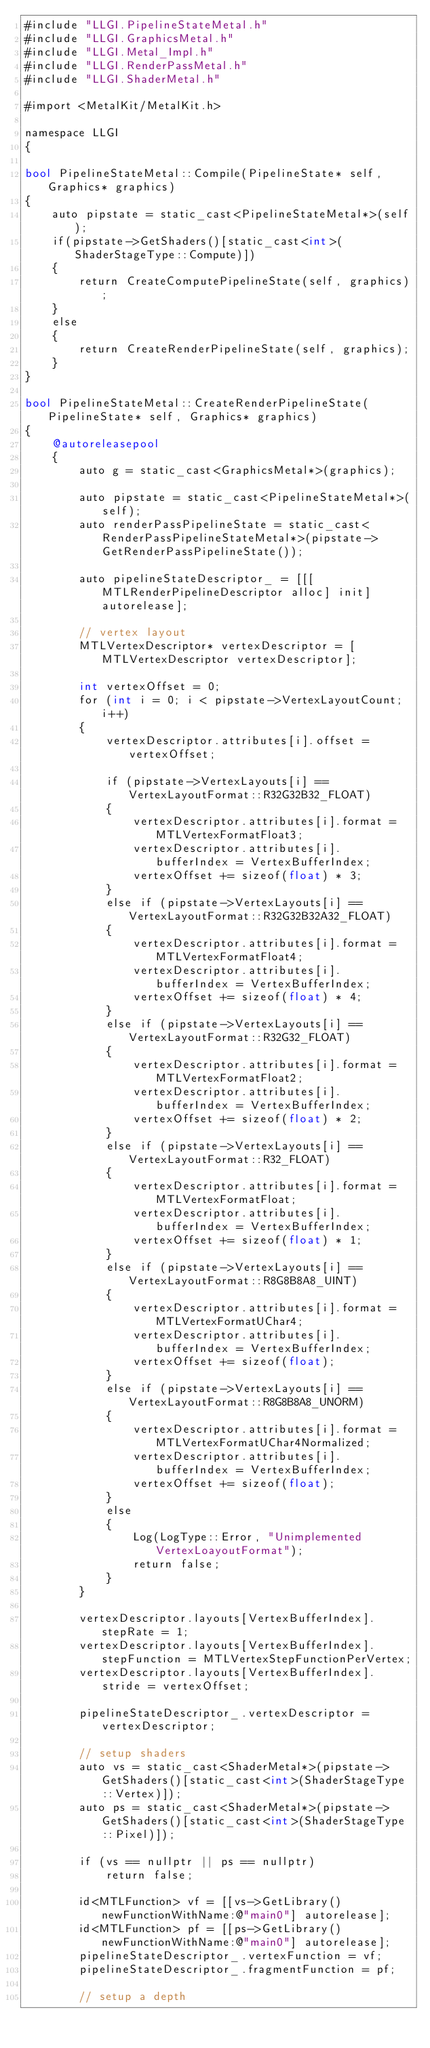Convert code to text. <code><loc_0><loc_0><loc_500><loc_500><_ObjectiveC_>#include "LLGI.PipelineStateMetal.h"
#include "LLGI.GraphicsMetal.h"
#include "LLGI.Metal_Impl.h"
#include "LLGI.RenderPassMetal.h"
#include "LLGI.ShaderMetal.h"

#import <MetalKit/MetalKit.h>

namespace LLGI
{

bool PipelineStateMetal::Compile(PipelineState* self, Graphics* graphics)
{
	auto pipstate = static_cast<PipelineStateMetal*>(self);
	if(pipstate->GetShaders()[static_cast<int>(ShaderStageType::Compute)])
	{
		return CreateComputePipelineState(self, graphics);
	}
	else
	{
		return CreateRenderPipelineState(self, graphics);
	}
}

bool PipelineStateMetal::CreateRenderPipelineState(PipelineState* self, Graphics* graphics)
{
	@autoreleasepool
	{
		auto g = static_cast<GraphicsMetal*>(graphics);

		auto pipstate = static_cast<PipelineStateMetal*>(self);
		auto renderPassPipelineState = static_cast<RenderPassPipelineStateMetal*>(pipstate->GetRenderPassPipelineState());

		auto pipelineStateDescriptor_ = [[[MTLRenderPipelineDescriptor alloc] init] autorelease];

		// vertex layout
		MTLVertexDescriptor* vertexDescriptor = [MTLVertexDescriptor vertexDescriptor];

		int vertexOffset = 0;
		for (int i = 0; i < pipstate->VertexLayoutCount; i++)
		{
			vertexDescriptor.attributes[i].offset = vertexOffset;

			if (pipstate->VertexLayouts[i] == VertexLayoutFormat::R32G32B32_FLOAT)
			{
				vertexDescriptor.attributes[i].format = MTLVertexFormatFloat3;
				vertexDescriptor.attributes[i].bufferIndex = VertexBufferIndex;
				vertexOffset += sizeof(float) * 3;
			}
			else if (pipstate->VertexLayouts[i] == VertexLayoutFormat::R32G32B32A32_FLOAT)
			{
				vertexDescriptor.attributes[i].format = MTLVertexFormatFloat4;
				vertexDescriptor.attributes[i].bufferIndex = VertexBufferIndex;
				vertexOffset += sizeof(float) * 4;
			}
			else if (pipstate->VertexLayouts[i] == VertexLayoutFormat::R32G32_FLOAT)
			{
				vertexDescriptor.attributes[i].format = MTLVertexFormatFloat2;
				vertexDescriptor.attributes[i].bufferIndex = VertexBufferIndex;
				vertexOffset += sizeof(float) * 2;
			}
			else if (pipstate->VertexLayouts[i] == VertexLayoutFormat::R32_FLOAT)
			{
				vertexDescriptor.attributes[i].format = MTLVertexFormatFloat;
				vertexDescriptor.attributes[i].bufferIndex = VertexBufferIndex;
				vertexOffset += sizeof(float) * 1;
			}
			else if (pipstate->VertexLayouts[i] == VertexLayoutFormat::R8G8B8A8_UINT)
			{
				vertexDescriptor.attributes[i].format = MTLVertexFormatUChar4;
				vertexDescriptor.attributes[i].bufferIndex = VertexBufferIndex;
				vertexOffset += sizeof(float);
			}
			else if (pipstate->VertexLayouts[i] == VertexLayoutFormat::R8G8B8A8_UNORM)
			{
				vertexDescriptor.attributes[i].format = MTLVertexFormatUChar4Normalized;
				vertexDescriptor.attributes[i].bufferIndex = VertexBufferIndex;
				vertexOffset += sizeof(float);
			}
			else
			{
				Log(LogType::Error, "Unimplemented VertexLoayoutFormat");
				return false;
			}
		}

		vertexDescriptor.layouts[VertexBufferIndex].stepRate = 1;
		vertexDescriptor.layouts[VertexBufferIndex].stepFunction = MTLVertexStepFunctionPerVertex;
		vertexDescriptor.layouts[VertexBufferIndex].stride = vertexOffset;

		pipelineStateDescriptor_.vertexDescriptor = vertexDescriptor;

		// setup shaders
		auto vs = static_cast<ShaderMetal*>(pipstate->GetShaders()[static_cast<int>(ShaderStageType::Vertex)]);
		auto ps = static_cast<ShaderMetal*>(pipstate->GetShaders()[static_cast<int>(ShaderStageType::Pixel)]);

		if (vs == nullptr || ps == nullptr)
			return false;

		id<MTLFunction> vf = [[vs->GetLibrary() newFunctionWithName:@"main0"] autorelease];
		id<MTLFunction> pf = [[ps->GetLibrary() newFunctionWithName:@"main0"] autorelease];
		pipelineStateDescriptor_.vertexFunction = vf;
		pipelineStateDescriptor_.fragmentFunction = pf;

		// setup a depth</code> 